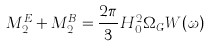<formula> <loc_0><loc_0><loc_500><loc_500>M _ { 2 } ^ { E } + M _ { 2 } ^ { B } = \frac { 2 \pi } { 3 } H _ { 0 } ^ { 2 } \Omega _ { G } W ( \omega )</formula> 